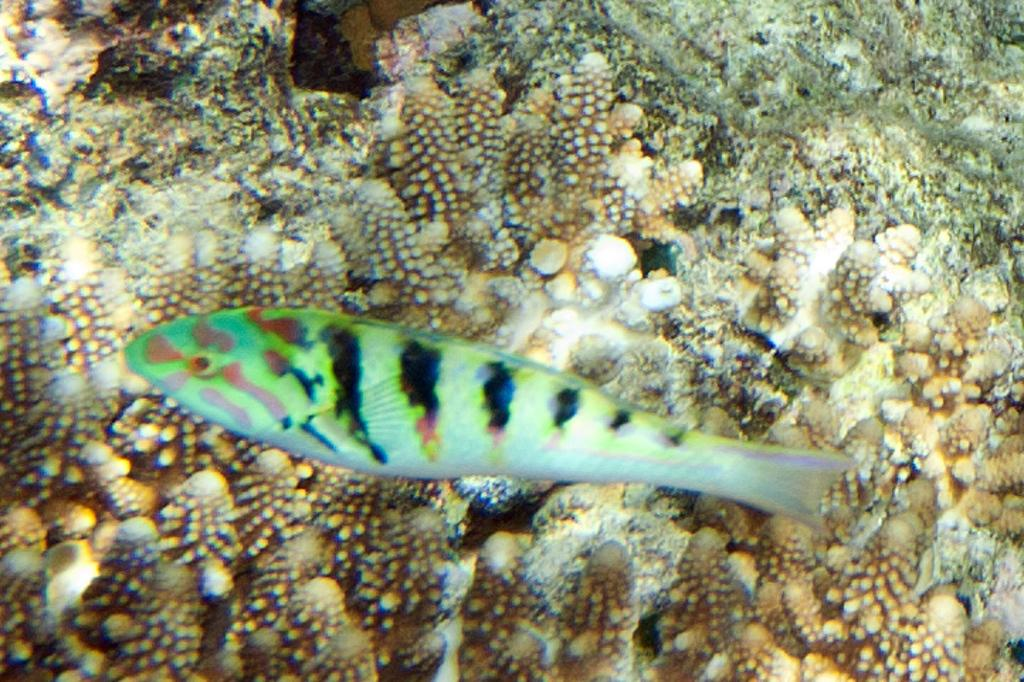What type of animal is present in the image? There is a green color fish in the image. What type of ladybug can be seen in the image? There is no ladybug present in the image; it features a green color fish. In which month was the image taken? The provided facts do not mention a specific month, so it cannot be determined from the information given. 